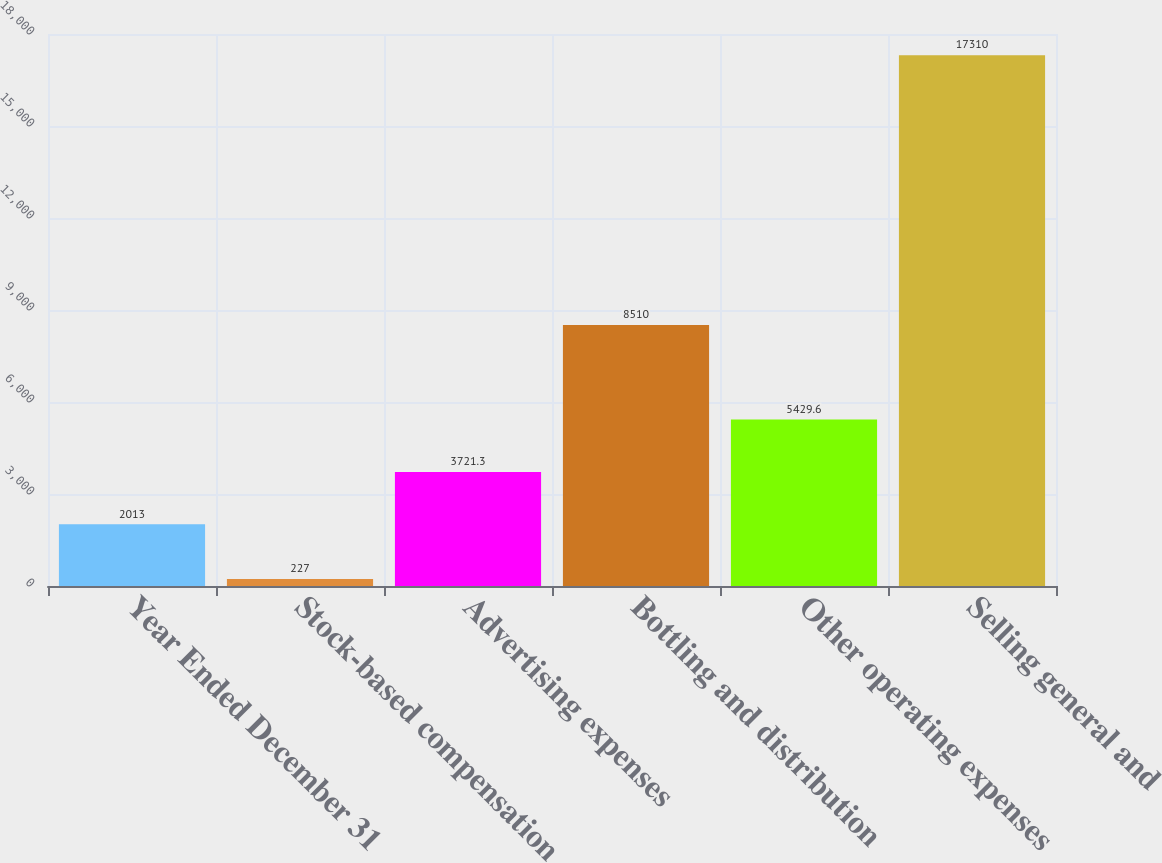Convert chart to OTSL. <chart><loc_0><loc_0><loc_500><loc_500><bar_chart><fcel>Year Ended December 31<fcel>Stock-based compensation<fcel>Advertising expenses<fcel>Bottling and distribution<fcel>Other operating expenses<fcel>Selling general and<nl><fcel>2013<fcel>227<fcel>3721.3<fcel>8510<fcel>5429.6<fcel>17310<nl></chart> 